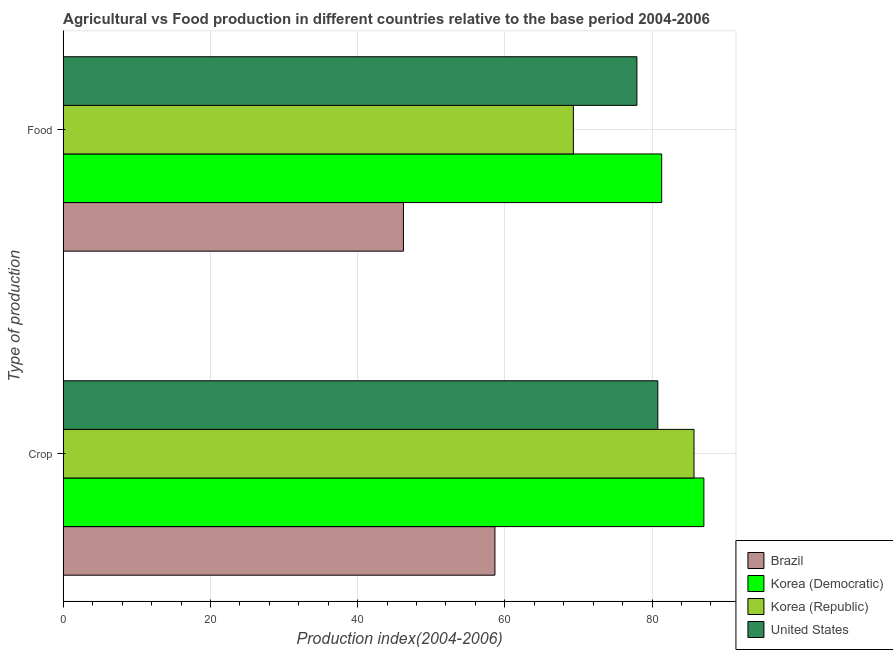How many different coloured bars are there?
Your answer should be very brief. 4. Are the number of bars per tick equal to the number of legend labels?
Your answer should be very brief. Yes. Are the number of bars on each tick of the Y-axis equal?
Your response must be concise. Yes. What is the label of the 1st group of bars from the top?
Give a very brief answer. Food. What is the food production index in Korea (Republic)?
Your answer should be very brief. 69.31. Across all countries, what is the maximum crop production index?
Make the answer very short. 87.04. Across all countries, what is the minimum food production index?
Give a very brief answer. 46.22. In which country was the food production index maximum?
Provide a short and direct response. Korea (Democratic). What is the total crop production index in the graph?
Offer a very short reply. 312.17. What is the difference between the crop production index in Korea (Republic) and that in Korea (Democratic)?
Give a very brief answer. -1.34. What is the difference between the crop production index in Korea (Democratic) and the food production index in Brazil?
Offer a terse response. 40.82. What is the average crop production index per country?
Keep it short and to the point. 78.04. What is the difference between the food production index and crop production index in Brazil?
Keep it short and to the point. -12.43. What is the ratio of the crop production index in Brazil to that in Korea (Republic)?
Your response must be concise. 0.68. Is the crop production index in Korea (Democratic) less than that in United States?
Offer a very short reply. No. What does the 2nd bar from the bottom in Crop represents?
Make the answer very short. Korea (Democratic). Are the values on the major ticks of X-axis written in scientific E-notation?
Your answer should be compact. No. Where does the legend appear in the graph?
Your answer should be compact. Bottom right. How many legend labels are there?
Provide a succinct answer. 4. How are the legend labels stacked?
Offer a terse response. Vertical. What is the title of the graph?
Keep it short and to the point. Agricultural vs Food production in different countries relative to the base period 2004-2006. Does "Faeroe Islands" appear as one of the legend labels in the graph?
Offer a terse response. No. What is the label or title of the X-axis?
Make the answer very short. Production index(2004-2006). What is the label or title of the Y-axis?
Offer a terse response. Type of production. What is the Production index(2004-2006) of Brazil in Crop?
Your answer should be compact. 58.65. What is the Production index(2004-2006) in Korea (Democratic) in Crop?
Your response must be concise. 87.04. What is the Production index(2004-2006) of Korea (Republic) in Crop?
Give a very brief answer. 85.7. What is the Production index(2004-2006) in United States in Crop?
Make the answer very short. 80.78. What is the Production index(2004-2006) of Brazil in Food?
Give a very brief answer. 46.22. What is the Production index(2004-2006) of Korea (Democratic) in Food?
Give a very brief answer. 81.31. What is the Production index(2004-2006) of Korea (Republic) in Food?
Your answer should be very brief. 69.31. What is the Production index(2004-2006) in United States in Food?
Provide a short and direct response. 77.94. Across all Type of production, what is the maximum Production index(2004-2006) in Brazil?
Ensure brevity in your answer.  58.65. Across all Type of production, what is the maximum Production index(2004-2006) of Korea (Democratic)?
Ensure brevity in your answer.  87.04. Across all Type of production, what is the maximum Production index(2004-2006) in Korea (Republic)?
Give a very brief answer. 85.7. Across all Type of production, what is the maximum Production index(2004-2006) of United States?
Your answer should be compact. 80.78. Across all Type of production, what is the minimum Production index(2004-2006) of Brazil?
Provide a succinct answer. 46.22. Across all Type of production, what is the minimum Production index(2004-2006) of Korea (Democratic)?
Offer a terse response. 81.31. Across all Type of production, what is the minimum Production index(2004-2006) in Korea (Republic)?
Make the answer very short. 69.31. Across all Type of production, what is the minimum Production index(2004-2006) of United States?
Ensure brevity in your answer.  77.94. What is the total Production index(2004-2006) of Brazil in the graph?
Your response must be concise. 104.87. What is the total Production index(2004-2006) in Korea (Democratic) in the graph?
Your answer should be compact. 168.35. What is the total Production index(2004-2006) in Korea (Republic) in the graph?
Give a very brief answer. 155.01. What is the total Production index(2004-2006) of United States in the graph?
Offer a very short reply. 158.72. What is the difference between the Production index(2004-2006) of Brazil in Crop and that in Food?
Your answer should be very brief. 12.43. What is the difference between the Production index(2004-2006) in Korea (Democratic) in Crop and that in Food?
Keep it short and to the point. 5.73. What is the difference between the Production index(2004-2006) of Korea (Republic) in Crop and that in Food?
Ensure brevity in your answer.  16.39. What is the difference between the Production index(2004-2006) in United States in Crop and that in Food?
Keep it short and to the point. 2.84. What is the difference between the Production index(2004-2006) of Brazil in Crop and the Production index(2004-2006) of Korea (Democratic) in Food?
Offer a very short reply. -22.66. What is the difference between the Production index(2004-2006) of Brazil in Crop and the Production index(2004-2006) of Korea (Republic) in Food?
Make the answer very short. -10.66. What is the difference between the Production index(2004-2006) of Brazil in Crop and the Production index(2004-2006) of United States in Food?
Offer a very short reply. -19.29. What is the difference between the Production index(2004-2006) in Korea (Democratic) in Crop and the Production index(2004-2006) in Korea (Republic) in Food?
Ensure brevity in your answer.  17.73. What is the difference between the Production index(2004-2006) of Korea (Republic) in Crop and the Production index(2004-2006) of United States in Food?
Ensure brevity in your answer.  7.76. What is the average Production index(2004-2006) of Brazil per Type of production?
Provide a succinct answer. 52.44. What is the average Production index(2004-2006) of Korea (Democratic) per Type of production?
Make the answer very short. 84.17. What is the average Production index(2004-2006) in Korea (Republic) per Type of production?
Provide a short and direct response. 77.5. What is the average Production index(2004-2006) in United States per Type of production?
Offer a terse response. 79.36. What is the difference between the Production index(2004-2006) of Brazil and Production index(2004-2006) of Korea (Democratic) in Crop?
Provide a succinct answer. -28.39. What is the difference between the Production index(2004-2006) in Brazil and Production index(2004-2006) in Korea (Republic) in Crop?
Make the answer very short. -27.05. What is the difference between the Production index(2004-2006) of Brazil and Production index(2004-2006) of United States in Crop?
Give a very brief answer. -22.13. What is the difference between the Production index(2004-2006) in Korea (Democratic) and Production index(2004-2006) in Korea (Republic) in Crop?
Provide a succinct answer. 1.34. What is the difference between the Production index(2004-2006) of Korea (Democratic) and Production index(2004-2006) of United States in Crop?
Make the answer very short. 6.26. What is the difference between the Production index(2004-2006) of Korea (Republic) and Production index(2004-2006) of United States in Crop?
Your answer should be compact. 4.92. What is the difference between the Production index(2004-2006) of Brazil and Production index(2004-2006) of Korea (Democratic) in Food?
Your answer should be compact. -35.09. What is the difference between the Production index(2004-2006) in Brazil and Production index(2004-2006) in Korea (Republic) in Food?
Your response must be concise. -23.09. What is the difference between the Production index(2004-2006) in Brazil and Production index(2004-2006) in United States in Food?
Give a very brief answer. -31.72. What is the difference between the Production index(2004-2006) in Korea (Democratic) and Production index(2004-2006) in United States in Food?
Ensure brevity in your answer.  3.37. What is the difference between the Production index(2004-2006) in Korea (Republic) and Production index(2004-2006) in United States in Food?
Your answer should be very brief. -8.63. What is the ratio of the Production index(2004-2006) in Brazil in Crop to that in Food?
Offer a very short reply. 1.27. What is the ratio of the Production index(2004-2006) of Korea (Democratic) in Crop to that in Food?
Keep it short and to the point. 1.07. What is the ratio of the Production index(2004-2006) in Korea (Republic) in Crop to that in Food?
Give a very brief answer. 1.24. What is the ratio of the Production index(2004-2006) in United States in Crop to that in Food?
Offer a terse response. 1.04. What is the difference between the highest and the second highest Production index(2004-2006) in Brazil?
Give a very brief answer. 12.43. What is the difference between the highest and the second highest Production index(2004-2006) of Korea (Democratic)?
Your response must be concise. 5.73. What is the difference between the highest and the second highest Production index(2004-2006) of Korea (Republic)?
Offer a terse response. 16.39. What is the difference between the highest and the second highest Production index(2004-2006) in United States?
Make the answer very short. 2.84. What is the difference between the highest and the lowest Production index(2004-2006) of Brazil?
Give a very brief answer. 12.43. What is the difference between the highest and the lowest Production index(2004-2006) in Korea (Democratic)?
Offer a very short reply. 5.73. What is the difference between the highest and the lowest Production index(2004-2006) in Korea (Republic)?
Give a very brief answer. 16.39. What is the difference between the highest and the lowest Production index(2004-2006) in United States?
Offer a very short reply. 2.84. 